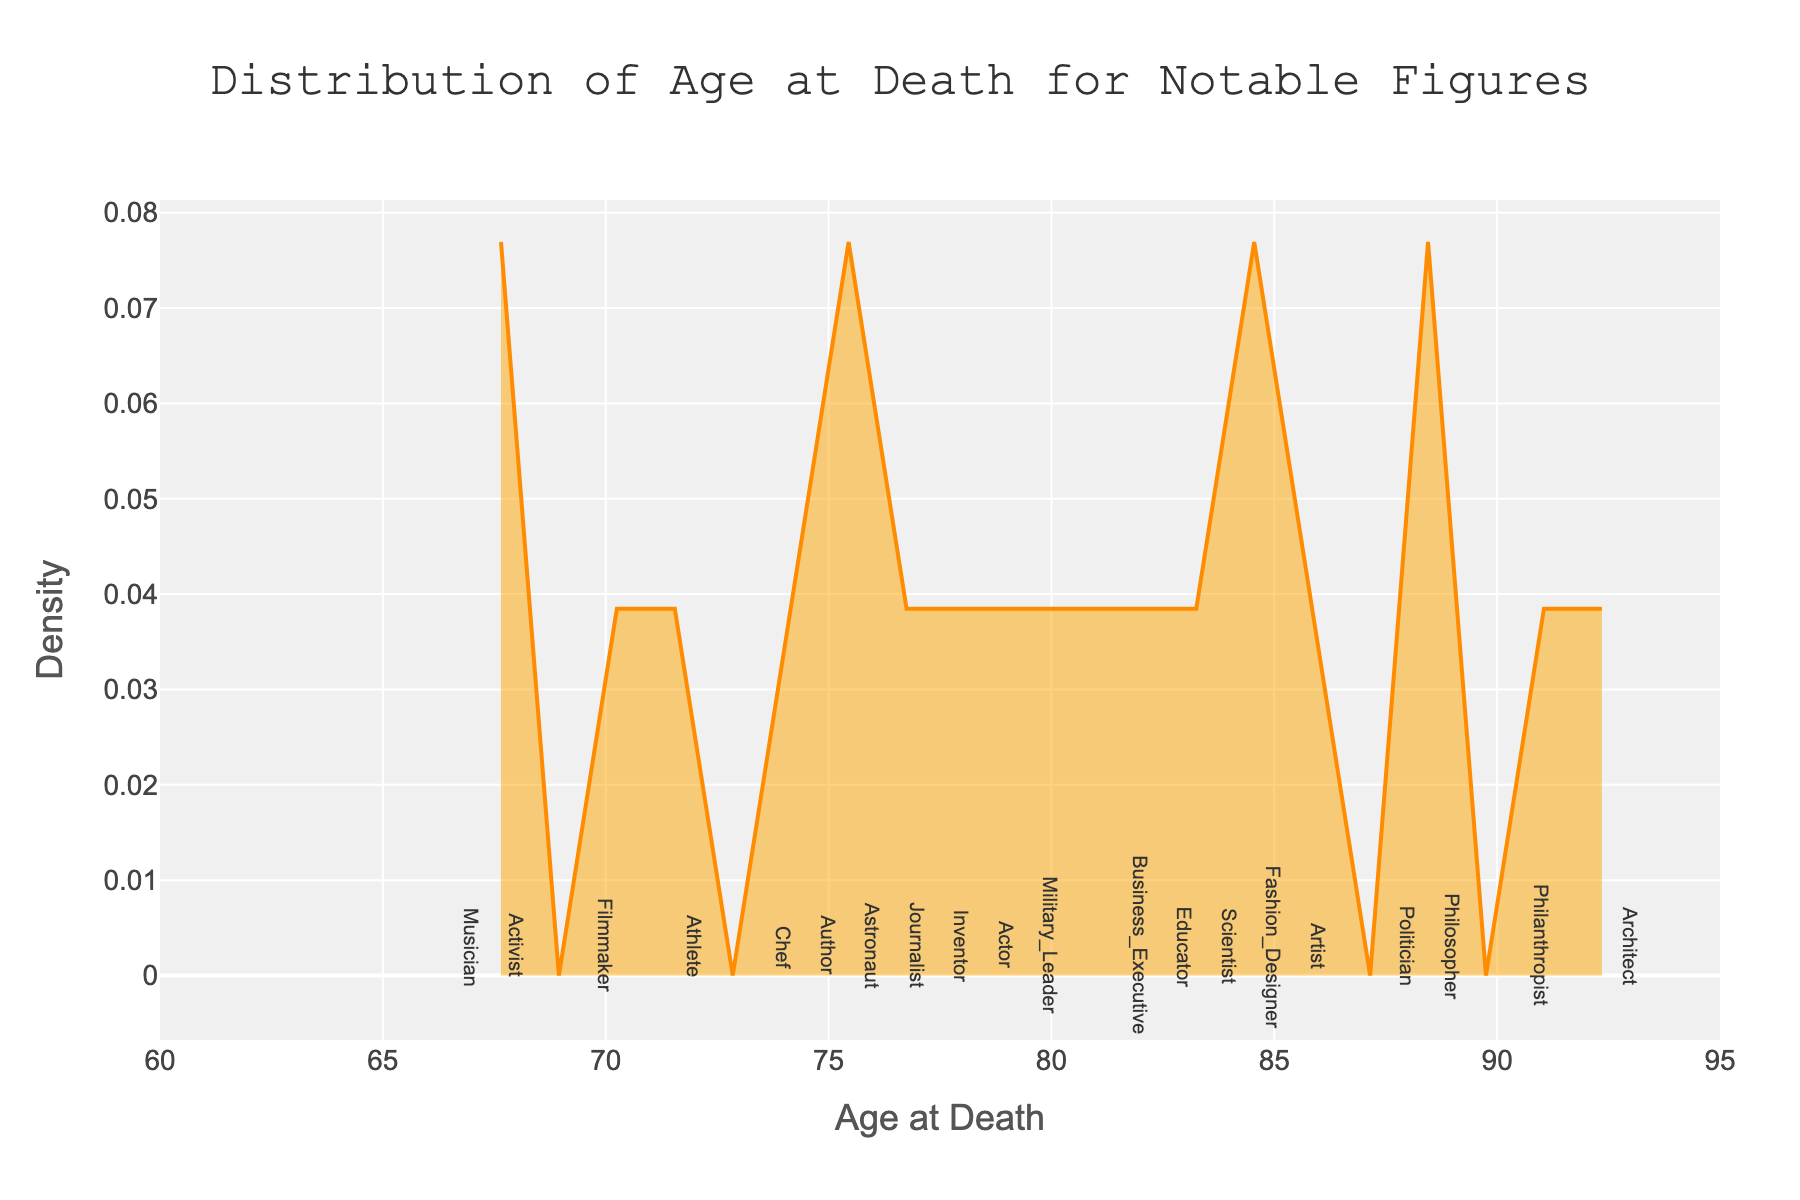What's the title of the figure? The title is centered at the top of the figure in a large font and reads "Distribution of Age at Death for Notable Figures".
Answer: Distribution of Age at Death for Notable Figures What is the age range shown on the x-axis? The x-axis range, indicated by the tick marks, spans from 60 to 95 years.
Answer: 60 to 95 years Which profession has the oldest age at death? The age at death for each profession is marked by a small dot on the plot. The rightmost dot, at 93 years, is labeled as "Architect".
Answer: Architect Which density value is plotted at the highest age? Find the highest age on the x-axis, which is 93, and trace it up to the curve. The corresponding y-axis value is the density value.
Answer: ~0.001 What is the age at death for the youngest journalist on the plot? Locate the label “Journalist” on the plot where the dot is placed. The dot for Journalist is at 77 years.
Answer: 77 years Which profession is represented by an age of death of 88? Find the dot situated at 88 years on the x-axis. The label next to it reads "Politician".
Answer: Politician Do more notable figures die before or after age 80? Count the number of data points (dots) positioned before and after age 80 on the x-axis. More than half of the dots are positioned after 80.
Answer: After 80 What is the profession for the data point at age 68? Locate the dot placed at 68 years on the x-axis. The label for this point is "Activist".
Answer: Activist What's the overall trend of the density curve? Observe the overall shape of the density curve: it starts low around 60, rises to a peak between 80-85, and then declines afterward.
Answer: Peaks around 80-85 Which age at death is the most frequent in this dataset? The age at the highest point of the density curve indicates the most common age of death. This peak is around 82-85 years.
Answer: 82-85 years 